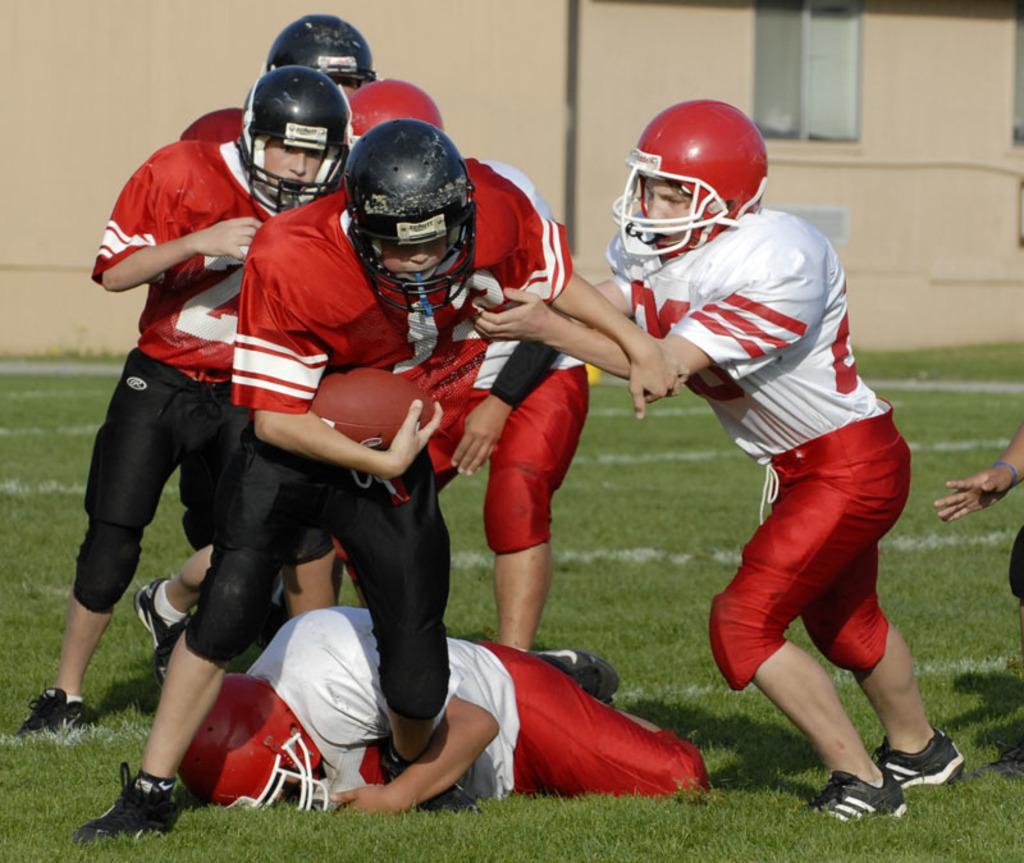Please provide a concise description of this image. In the center of the image there are persons playing in the ground. In the background there is a building. 